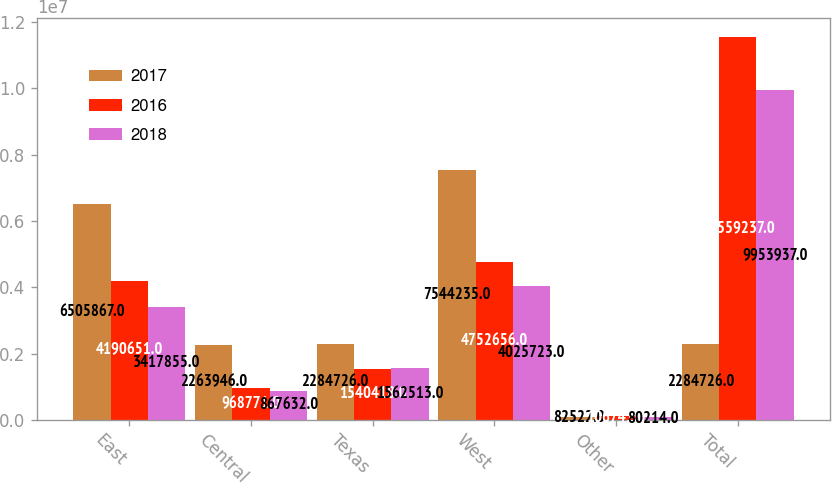<chart> <loc_0><loc_0><loc_500><loc_500><stacked_bar_chart><ecel><fcel>East<fcel>Central<fcel>Texas<fcel>West<fcel>Other<fcel>Total<nl><fcel>2017<fcel>6.50587e+06<fcel>2.26395e+06<fcel>2.28473e+06<fcel>7.54424e+06<fcel>82522<fcel>2.28473e+06<nl><fcel>2016<fcel>4.19065e+06<fcel>968771<fcel>1.54042e+06<fcel>4.75266e+06<fcel>106741<fcel>1.15592e+07<nl><fcel>2018<fcel>3.41786e+06<fcel>867632<fcel>1.56251e+06<fcel>4.02572e+06<fcel>80214<fcel>9.95394e+06<nl></chart> 